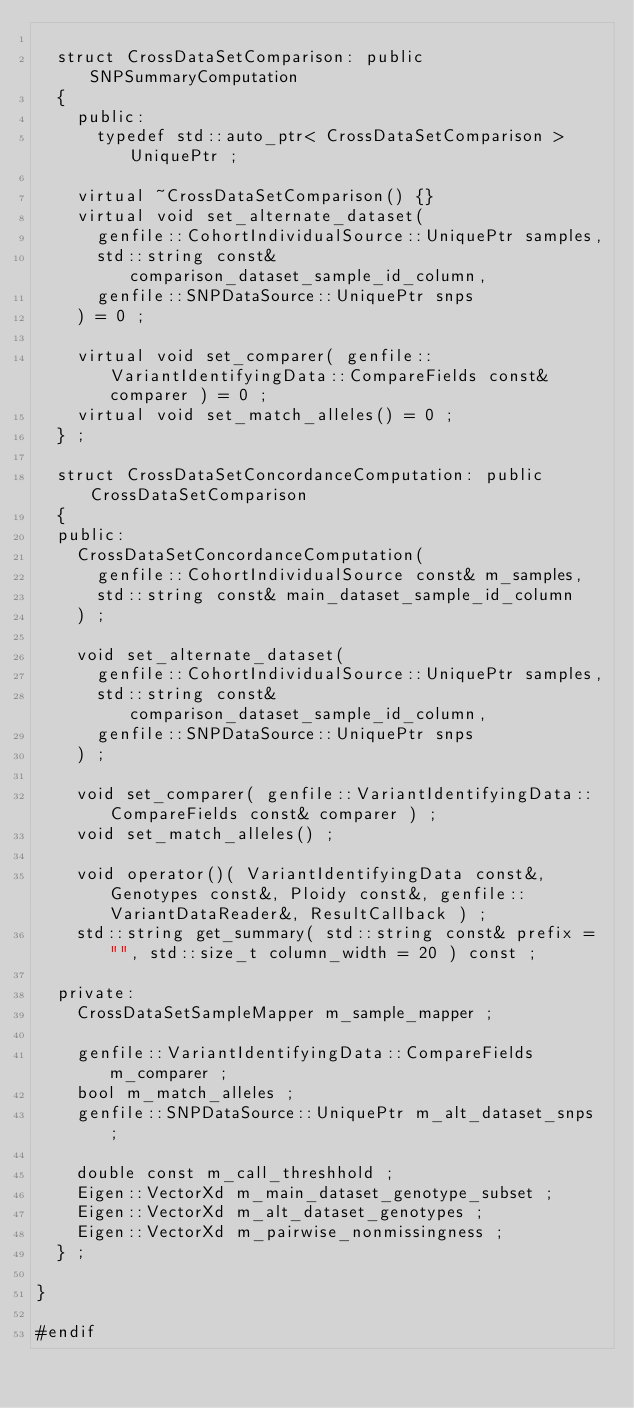<code> <loc_0><loc_0><loc_500><loc_500><_C++_>
	struct CrossDataSetComparison: public SNPSummaryComputation
	{
		public:
			typedef std::auto_ptr< CrossDataSetComparison > UniquePtr ;
		
		virtual ~CrossDataSetComparison() {}
		virtual void set_alternate_dataset(
			genfile::CohortIndividualSource::UniquePtr samples,
			std::string const& comparison_dataset_sample_id_column,
			genfile::SNPDataSource::UniquePtr snps
		) = 0 ;
		
		virtual void set_comparer( genfile::VariantIdentifyingData::CompareFields const& comparer ) = 0 ;
		virtual void set_match_alleles() = 0 ;
	} ;

	struct CrossDataSetConcordanceComputation: public CrossDataSetComparison
	{
	public:
		CrossDataSetConcordanceComputation(
			genfile::CohortIndividualSource const& m_samples,
			std::string const& main_dataset_sample_id_column
		) ;

		void set_alternate_dataset(
			genfile::CohortIndividualSource::UniquePtr samples,
			std::string const& comparison_dataset_sample_id_column,
			genfile::SNPDataSource::UniquePtr snps
		) ;
		
		void set_comparer( genfile::VariantIdentifyingData::CompareFields const& comparer ) ;
		void set_match_alleles() ;
		
		void operator()( VariantIdentifyingData const&, Genotypes const&, Ploidy const&, genfile::VariantDataReader&, ResultCallback ) ;
		std::string get_summary( std::string const& prefix = "", std::size_t column_width = 20 ) const ;

	private:
		CrossDataSetSampleMapper m_sample_mapper ;

		genfile::VariantIdentifyingData::CompareFields m_comparer ;
		bool m_match_alleles ;
		genfile::SNPDataSource::UniquePtr m_alt_dataset_snps ;

		double const m_call_threshhold ;
		Eigen::VectorXd m_main_dataset_genotype_subset ;
		Eigen::VectorXd m_alt_dataset_genotypes ;
		Eigen::VectorXd m_pairwise_nonmissingness ;
	} ;

}

#endif
</code> 